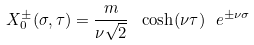<formula> <loc_0><loc_0><loc_500><loc_500>X ^ { \pm } _ { 0 } ( \sigma , \tau ) = \frac { m } { \nu \sqrt { 2 } } \ \cosh ( \nu \tau ) \ e ^ { \pm \nu \sigma }</formula> 